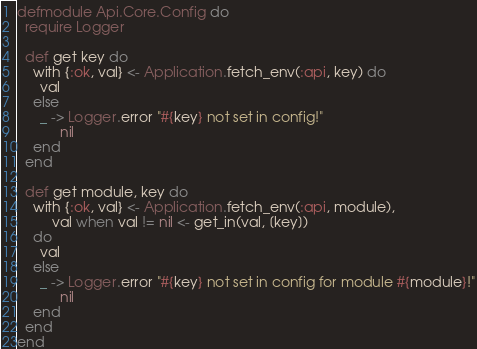Convert code to text. <code><loc_0><loc_0><loc_500><loc_500><_Elixir_>defmodule Api.Core.Config do
  require Logger

  def get key do
    with {:ok, val} <- Application.fetch_env(:api, key) do
      val
    else
      _ -> Logger.error "#{key} not set in config!"
           nil
    end
  end

  def get module, key do
    with {:ok, val} <- Application.fetch_env(:api, module),
         val when val != nil <- get_in(val, [key])
    do
      val
    else
      _ -> Logger.error "#{key} not set in config for module #{module}!"
           nil
    end
  end
end
</code> 